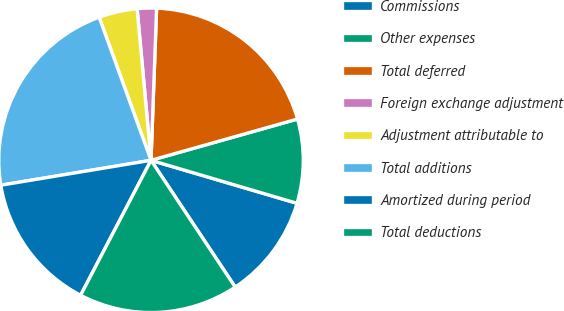<chart> <loc_0><loc_0><loc_500><loc_500><pie_chart><fcel>Commissions<fcel>Other expenses<fcel>Total deferred<fcel>Foreign exchange adjustment<fcel>Adjustment attributable to<fcel>Total additions<fcel>Amortized during period<fcel>Total deductions<nl><fcel>11.11%<fcel>8.93%<fcel>20.04%<fcel>2.04%<fcel>4.08%<fcel>22.08%<fcel>14.73%<fcel>16.98%<nl></chart> 